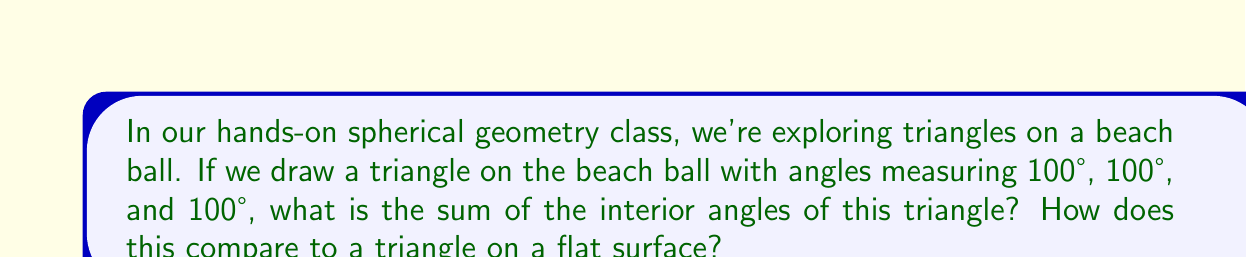Teach me how to tackle this problem. Let's approach this step-by-step:

1) In Euclidean (flat) geometry, the sum of interior angles of a triangle is always 180°. However, on a spherical surface, this rule doesn't apply.

2) On a sphere, the sum of the interior angles of a triangle is always greater than 180°. This excess over 180° is called the spherical excess.

3) For a triangle on a sphere, the sum of the interior angles is given by the formula:

   $$S = 180° + A$$

   where $S$ is the sum of the angles and $A$ is the area of the triangle in steradians.

4) In our case, we're given the three angles of the triangle:
   $$100° + 100° + 100° = 300°$$

5) We can see that the sum is indeed greater than 180°, confirming that this is a spherical triangle.

6) The spherical excess in this case is:
   $$300° - 180° = 120°$$

7) Comparing to a flat surface:
   - On a flat surface, a triangle with these angle measures would be impossible.
   - The sum exceeds 180° by 120°, which is a significant deviation from Euclidean geometry.

This demonstrates a key property of spherical triangles: their interior angles can sum to more than 180°, unlike triangles on a flat surface.
Answer: 300°; 120° more than a flat triangle 